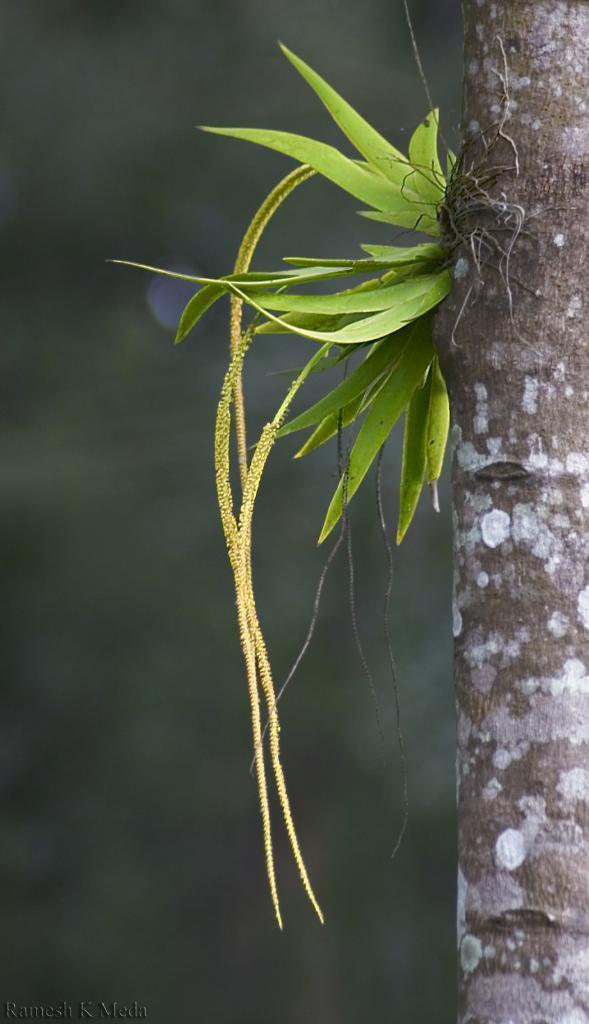What is present in the image? There is a plant in the image. Where is the plant located in relation to other objects? The plant is near a trunk. Can you describe the background of the image? The background of the image is blurred. What size is the tent in the image? There is no tent present in the image. 